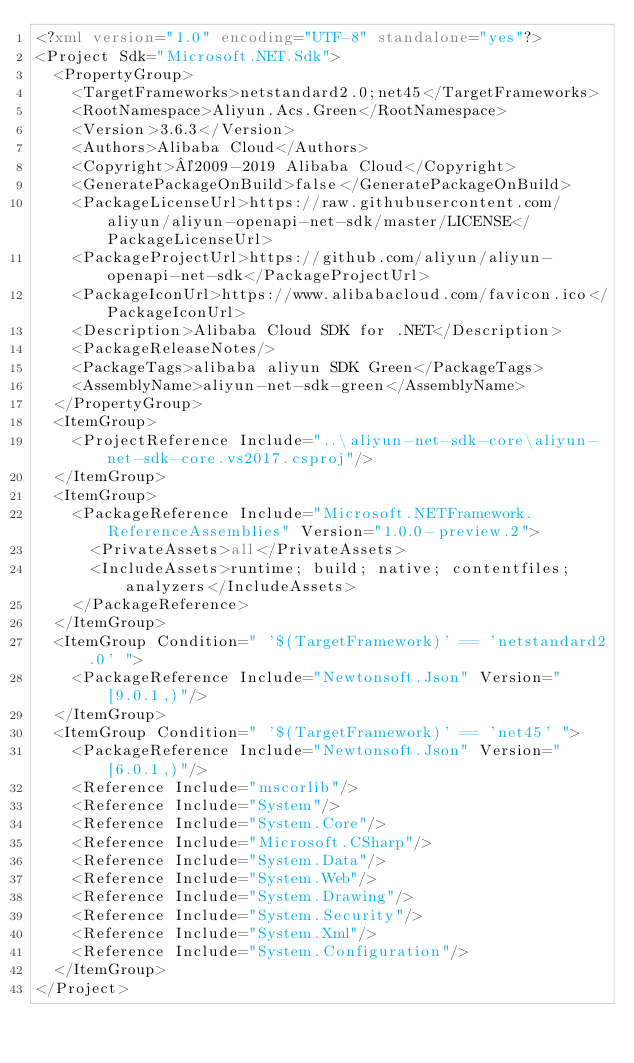<code> <loc_0><loc_0><loc_500><loc_500><_XML_><?xml version="1.0" encoding="UTF-8" standalone="yes"?>
<Project Sdk="Microsoft.NET.Sdk">
  <PropertyGroup>
    <TargetFrameworks>netstandard2.0;net45</TargetFrameworks>
    <RootNamespace>Aliyun.Acs.Green</RootNamespace>
    <Version>3.6.3</Version>
    <Authors>Alibaba Cloud</Authors>
    <Copyright>©2009-2019 Alibaba Cloud</Copyright>
    <GeneratePackageOnBuild>false</GeneratePackageOnBuild>
    <PackageLicenseUrl>https://raw.githubusercontent.com/aliyun/aliyun-openapi-net-sdk/master/LICENSE</PackageLicenseUrl>
    <PackageProjectUrl>https://github.com/aliyun/aliyun-openapi-net-sdk</PackageProjectUrl>
    <PackageIconUrl>https://www.alibabacloud.com/favicon.ico</PackageIconUrl>
    <Description>Alibaba Cloud SDK for .NET</Description>
    <PackageReleaseNotes/>
    <PackageTags>alibaba aliyun SDK Green</PackageTags>
    <AssemblyName>aliyun-net-sdk-green</AssemblyName>
  </PropertyGroup>
  <ItemGroup>
    <ProjectReference Include="..\aliyun-net-sdk-core\aliyun-net-sdk-core.vs2017.csproj"/>
  </ItemGroup>
  <ItemGroup>
    <PackageReference Include="Microsoft.NETFramework.ReferenceAssemblies" Version="1.0.0-preview.2">
      <PrivateAssets>all</PrivateAssets>
      <IncludeAssets>runtime; build; native; contentfiles; analyzers</IncludeAssets>
    </PackageReference>
  </ItemGroup>
  <ItemGroup Condition=" '$(TargetFramework)' == 'netstandard2.0' ">
    <PackageReference Include="Newtonsoft.Json" Version="[9.0.1,)"/>
  </ItemGroup>
  <ItemGroup Condition=" '$(TargetFramework)' == 'net45' ">
    <PackageReference Include="Newtonsoft.Json" Version="[6.0.1,)"/>
    <Reference Include="mscorlib"/>
    <Reference Include="System"/>
    <Reference Include="System.Core"/>
    <Reference Include="Microsoft.CSharp"/>
    <Reference Include="System.Data"/>
    <Reference Include="System.Web"/>
    <Reference Include="System.Drawing"/>
    <Reference Include="System.Security"/>
    <Reference Include="System.Xml"/>
    <Reference Include="System.Configuration"/>
  </ItemGroup>
</Project></code> 